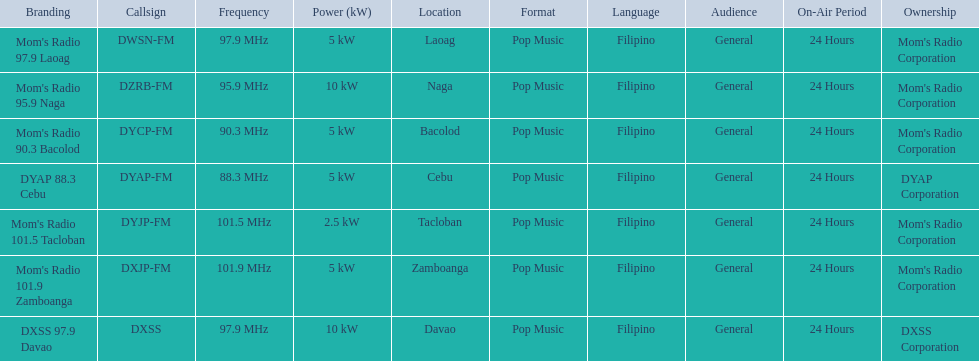What is the power capacity in kw for each team? 5 kW, 10 kW, 5 kW, 5 kW, 2.5 kW, 5 kW, 10 kW. Which is the lowest? 2.5 kW. What station has this amount of power? Mom's Radio 101.5 Tacloban. 